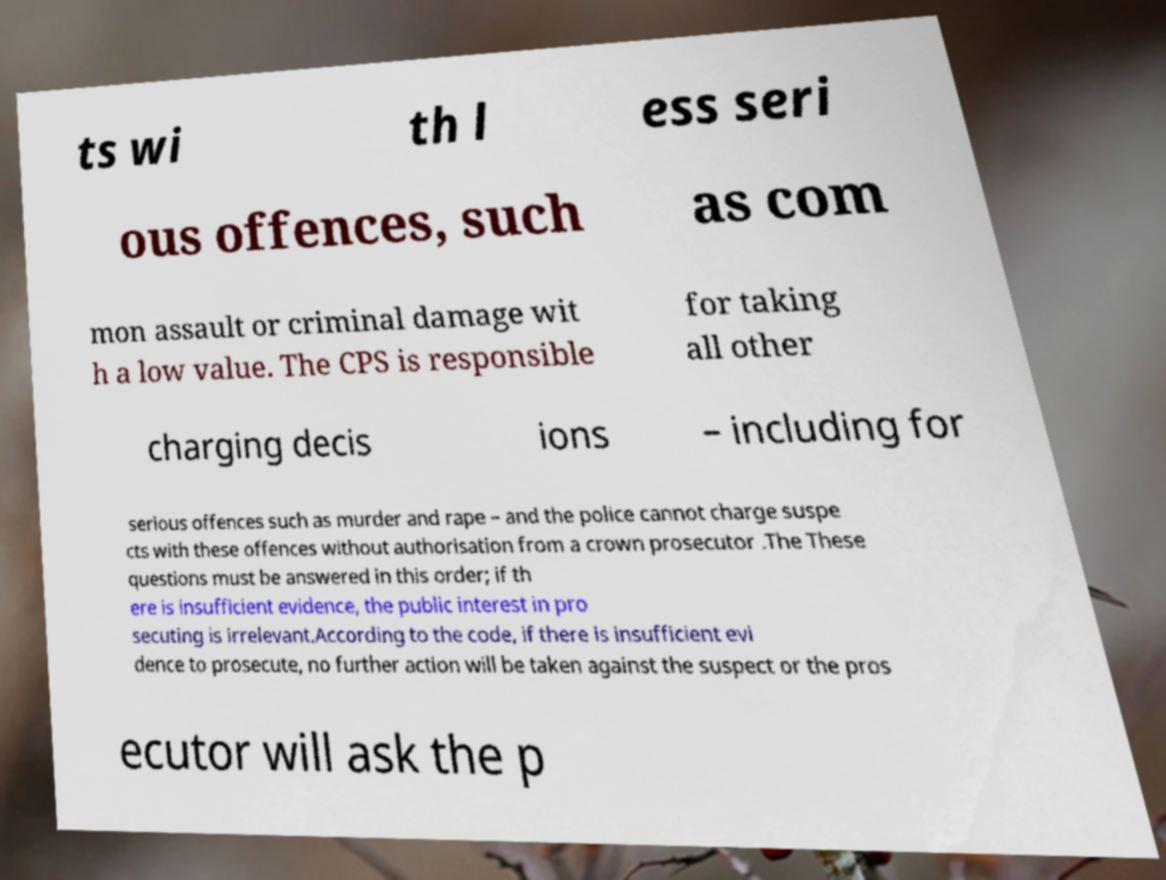Can you read and provide the text displayed in the image?This photo seems to have some interesting text. Can you extract and type it out for me? ts wi th l ess seri ous offences, such as com mon assault or criminal damage wit h a low value. The CPS is responsible for taking all other charging decis ions – including for serious offences such as murder and rape – and the police cannot charge suspe cts with these offences without authorisation from a crown prosecutor .The These questions must be answered in this order; if th ere is insufficient evidence, the public interest in pro secuting is irrelevant.According to the code, if there is insufficient evi dence to prosecute, no further action will be taken against the suspect or the pros ecutor will ask the p 